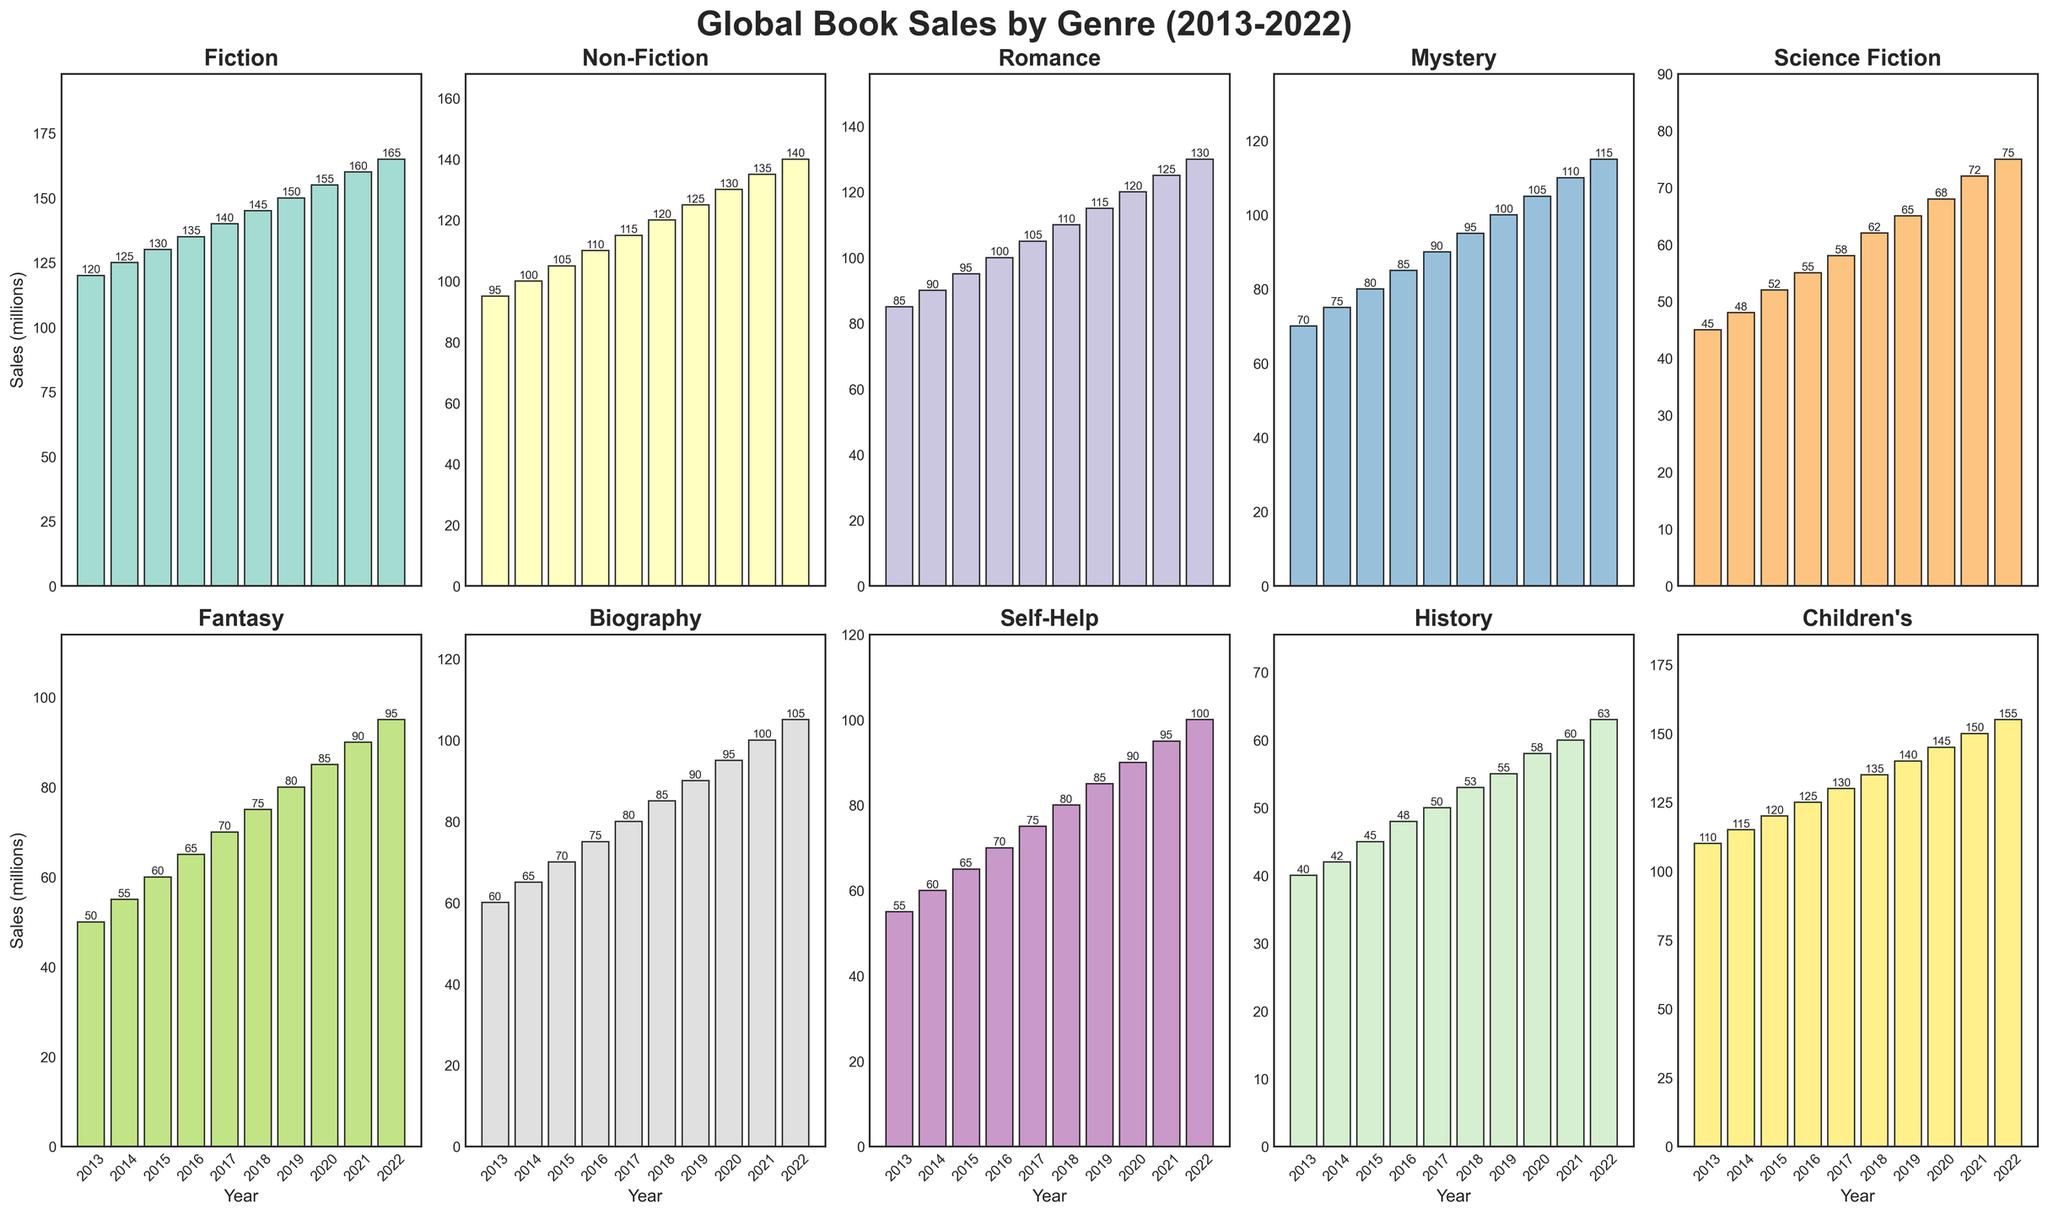Which genre had the highest book sales in 2022? Look at the bars representing the year 2022 in each subplot and compare their heights. The one with the highest value represents the genre with the highest sales. The "Children's" genre has the highest value at 155 million.
Answer: Children's Over the past decade, which genre saw the greatest absolute increase in book sales? To find the genre with the greatest absolute increase, subtract the value in 2013 from the value in 2022 for each genre. The calculations show the increases: Fiction (165-120=45), Non-Fiction (140-95=45), Romance (130-85=45), Mystery (115-70=45), Science Fiction (75-45=30), Fantasy (95-50=45), Biography (105-60=45), Self-Help (100-55=45), History (63-40=23), Children's (155-110=45). Therefore, Fiction, Non-Fiction, Romance, Mystery, Fantasy, Biography, Self-Help, and Children's all had an equal maximum increase of 45 million each.
Answer: Fiction, Non-Fiction, Romance, Mystery, Fantasy, Biography, Self-Help, Children's Between 2018 and 2022, which genre experienced the highest average annual growth in book sales? Calculate the average annual growth for each genre from 2018 to 2022 by dividing the total growth over these years by the number of years (2022-2018 = 4). For Fiction: (165-145)/4 = 5, Non-Fiction: (140-120)/4 = 5, Romance: (130-110)/4 = 5, Mystery: (115-95)/4 = 5, Science Fiction: (75-62)/4 = 3.25, Fantasy: (95-75)/4 = 5, Biography: (105-85)/4 = 5, Self-Help: (100-80)/4 = 5, History: (63-53)/4 = 2.5, Children's: (155-135)/4 = 5. The genres Fiction, Non-Fiction, Romance, Mystery, Fantasy, Biography, Self-Help, and Children's all experienced the highest average annual growth, i.e., 5 million per year.
Answer: Fiction, Non-Fiction, Romance, Mystery, Fantasy, Biography, Self-Help, Children's Which genre had the lowst sales in 2015 and how much were the sales? Compare the sales values of all genres for the year 2015 by examining the bars' heights. The "Science Fiction" genre has the lowest sales value at 52 million.
Answer: Science Fiction, 52 million Which two genres had the most similar sales in 2017, and what were their respective sales amounts? Check the sales values for all genres in 2017 and pick the two genres with the closest values. The "Children's" genre had sales of 130 million and the "Fiction" genre followed closely with 140 million.
Answer: Fiction, Children's - 140 million, 130 million What is the percentage increase in book sales for the Mystery genre from 2013 to 2022? Calculate the percentage increase by subtracting the 2013 sales from the 2022 sales, dividing by the 2013 sales, and then multiplying by 100. That is ((115-70)/70) * 100 = 64.29%.
Answer: 64.29% Which genre had relatively stable sales throughout the decade with the least fluctuations in book sales? Looking at the consistency of the bars’ heights for each genre over the years, "History" appears to have the least fluctuation, growing gradually from 40 million in 2013 to 63 million in 2022.
Answer: History 